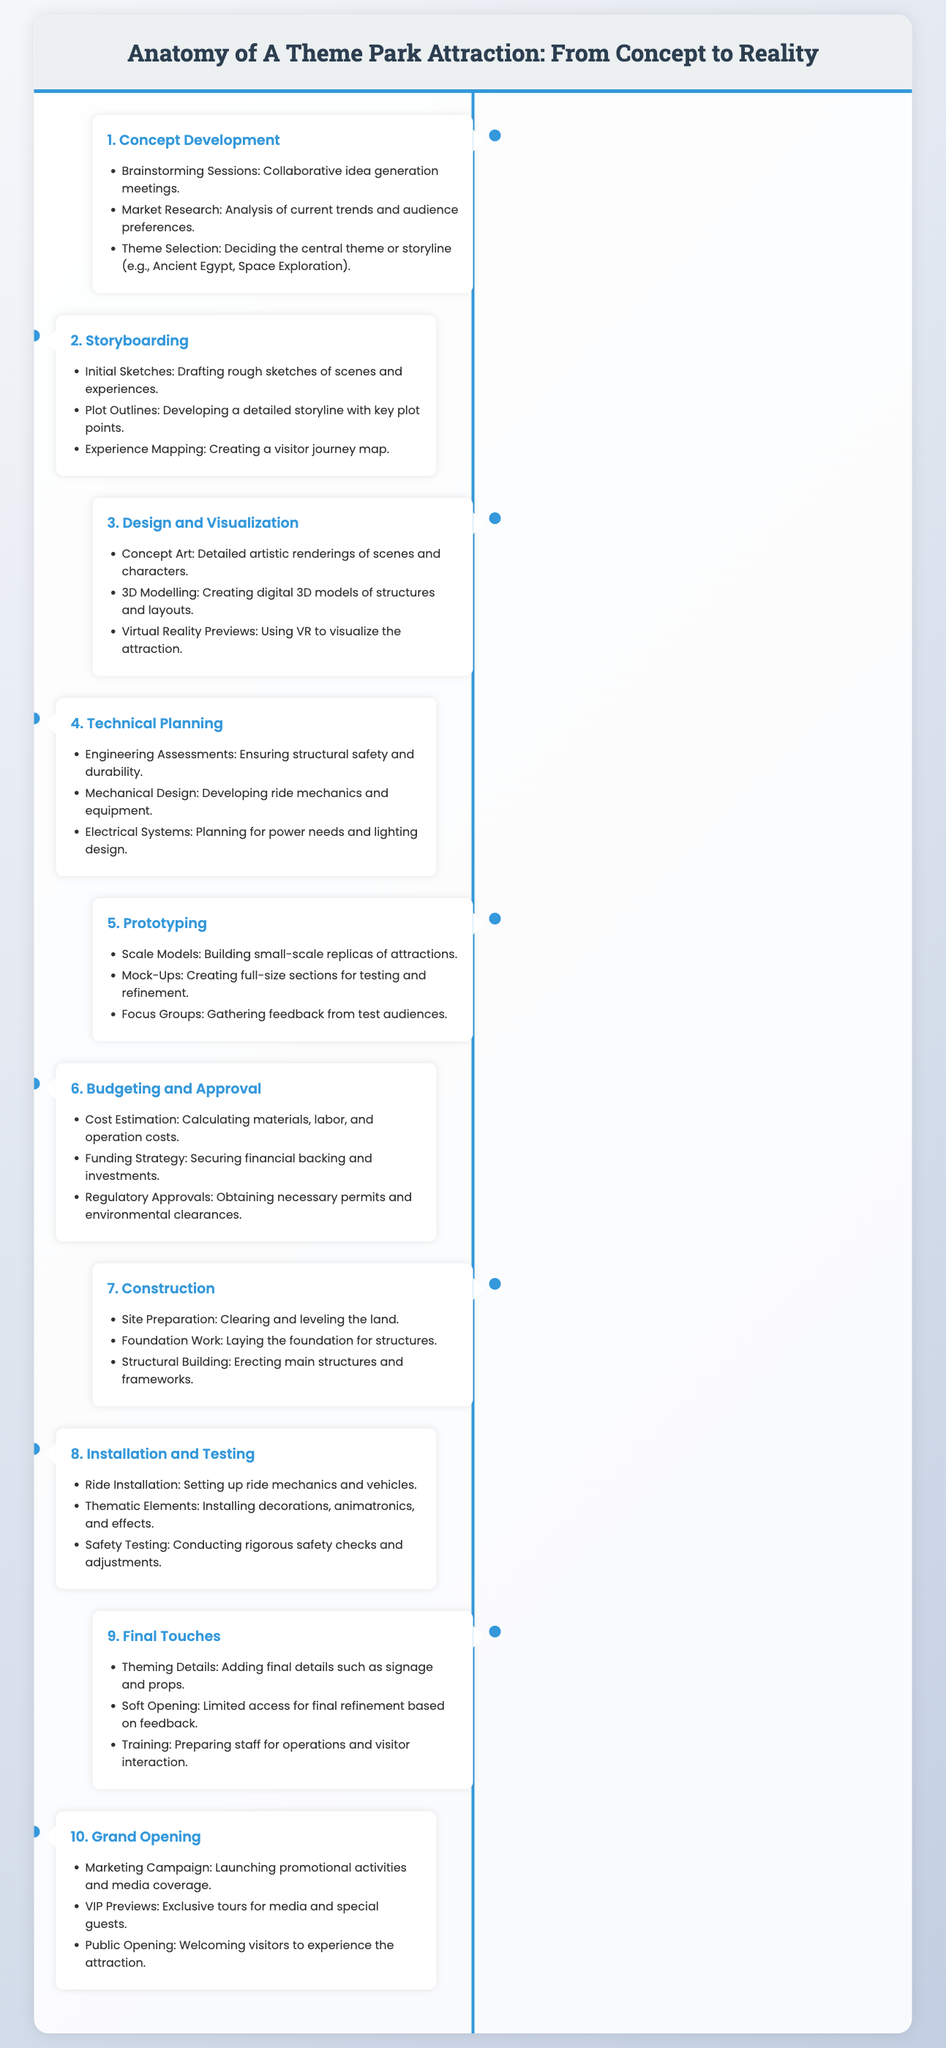What is the first stage of the attraction development process? The first stage is Concept Development, as shown in the flowchart.
Answer: Concept Development How many main stages are outlined in the document? The document lists a total of ten main stages from Concept to Grand Opening.
Answer: Ten What does the timeline item "3. Design and Visualization" include? This item includes Concept Art, 3D Modelling, and Virtual Reality Previews, which are listed under that stage.
Answer: Concept Art, 3D Modelling, Virtual Reality Previews Which stage involves gathering feedback from test audiences? The stage related to gathering feedback is Prototyping, which is mentioned in that context.
Answer: Prototyping What is the purpose of the "Soft Opening" stage? The Soft Opening stage is intended for limited access to refine operations based on feedback, as indicated.
Answer: Limited access for final refinement What is included in the "Final Touches" stage? The Final Touches stage includes theming details, soft opening, and training for staff.
Answer: Theming Details, Soft Opening, Training What happens during the "Grand Opening"? During the Grand Opening, a marketing campaign, VIP previews, and public opening occur.
Answer: Marketing Campaign, VIP Previews, Public Opening What is the last stage in the attraction development process? The last stage listed in the flowchart is the Grand Opening.
Answer: Grand Opening 